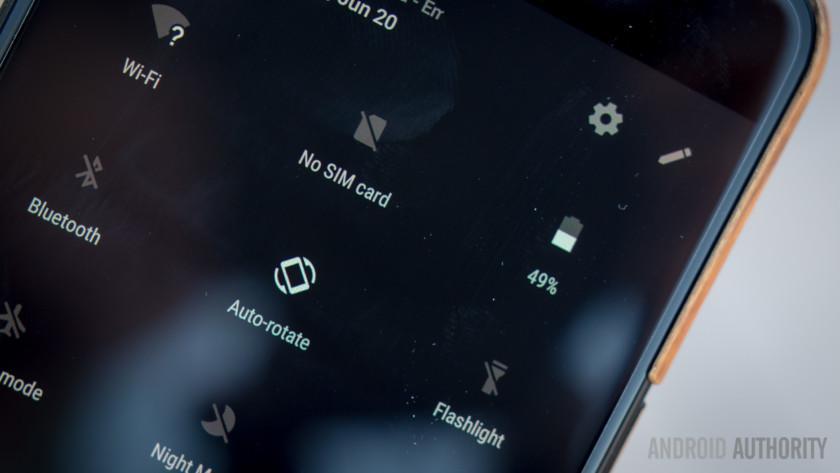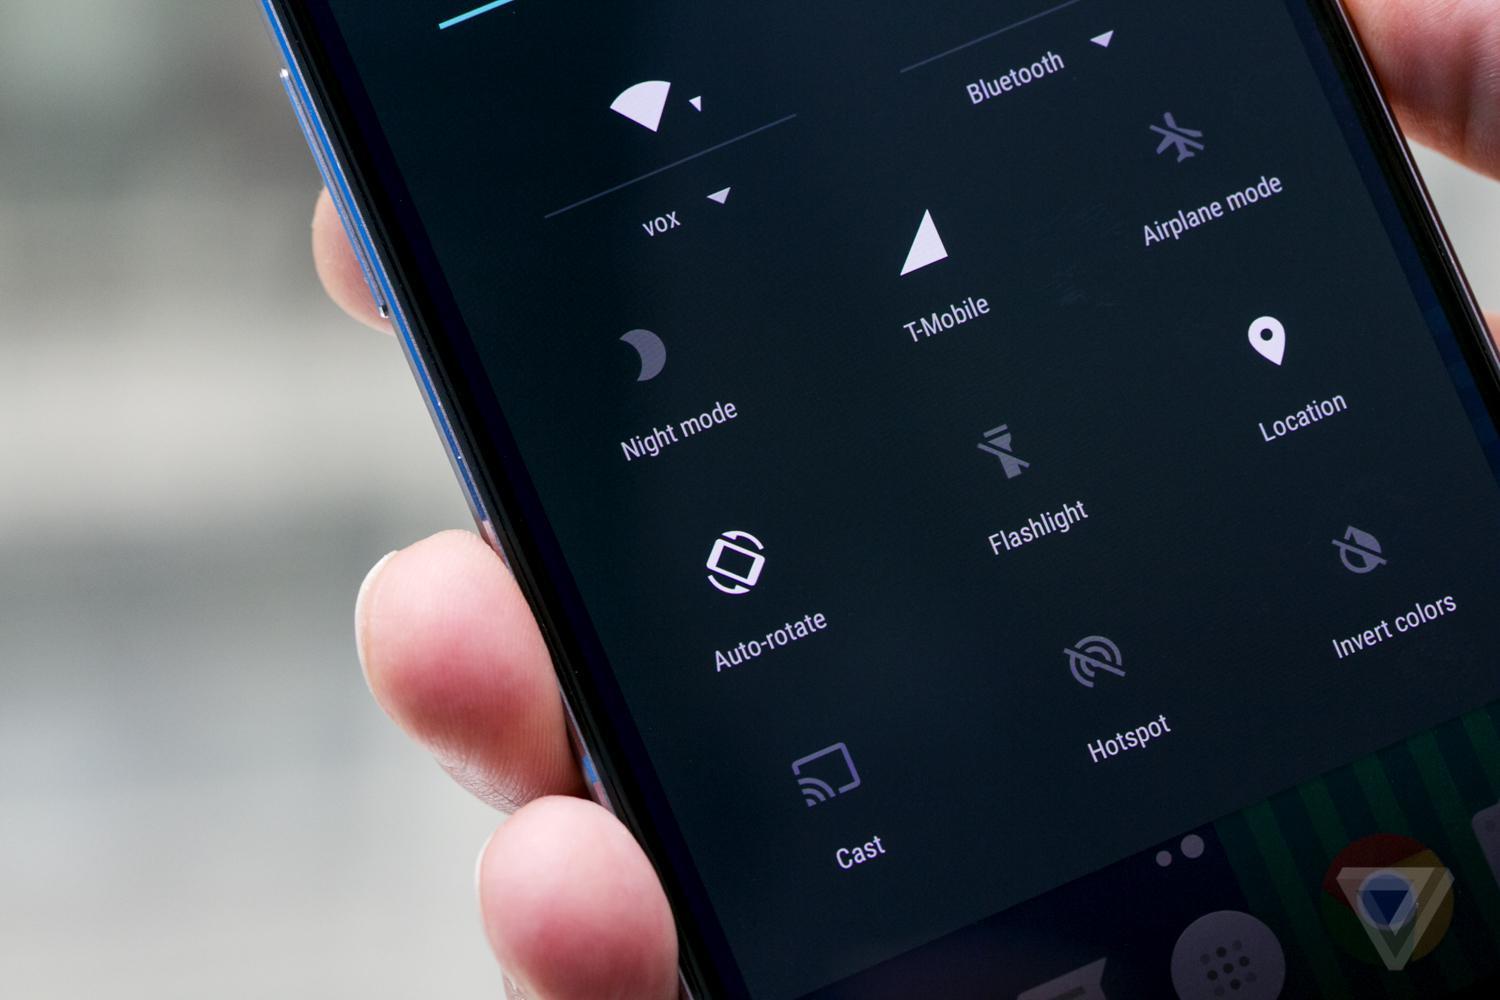The first image is the image on the left, the second image is the image on the right. Assess this claim about the two images: "A person is holding the phone in the image on the right.". Correct or not? Answer yes or no. Yes. The first image is the image on the left, the second image is the image on the right. Given the left and right images, does the statement "The right image shows a hand holding a rectangular screen-front device angled to the left." hold true? Answer yes or no. Yes. 